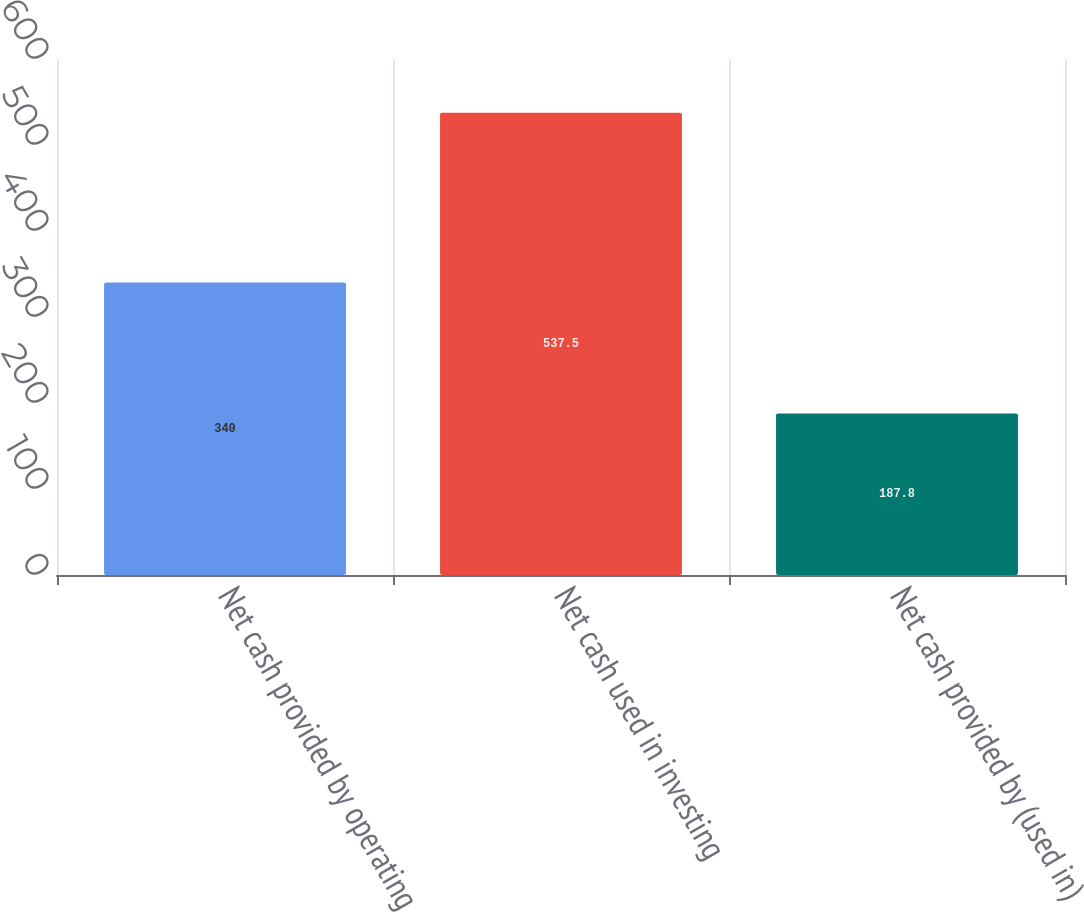<chart> <loc_0><loc_0><loc_500><loc_500><bar_chart><fcel>Net cash provided by operating<fcel>Net cash used in investing<fcel>Net cash provided by (used in)<nl><fcel>340<fcel>537.5<fcel>187.8<nl></chart> 